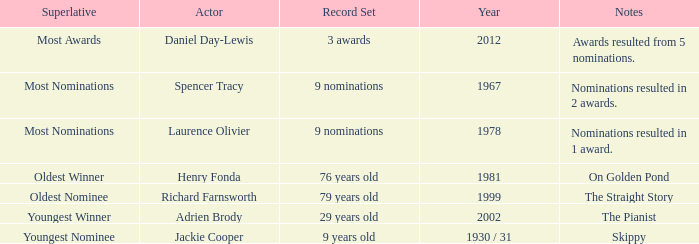In which year did the most senior winner emerge? 1981.0. 